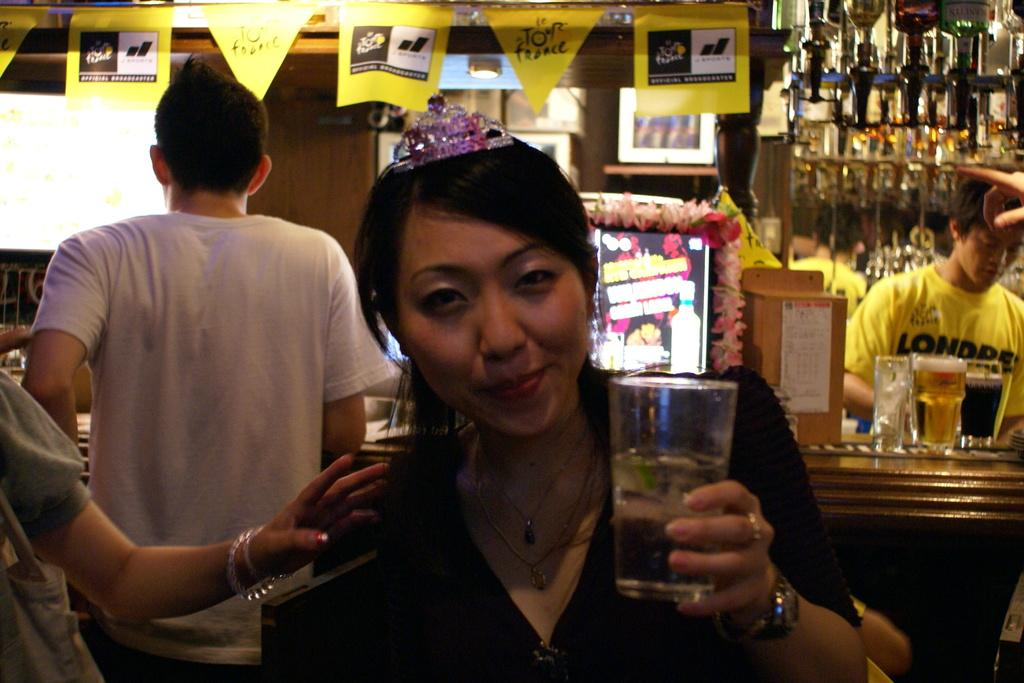How many people are in the image? There are people in the image, but the exact number is not specified. What is present in the image besides people? There is a table, posters, and glasses in the image. Can you describe the woman's position in the image? A woman is standing in the front of the image. What is the woman wearing? The woman is wearing a black color shirt. What is the woman holding in the image? The woman is holding a glass. How many crows are sitting on the pizzas in the image? There are no crows or pizzas present in the image. What type of hydrant is visible in the image? There is no hydrant present in the image. 